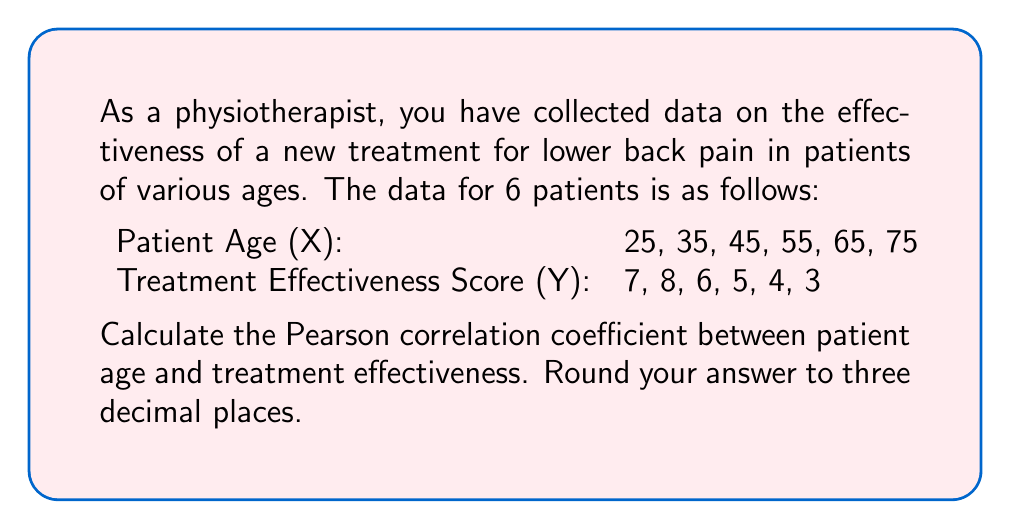Give your solution to this math problem. To calculate the Pearson correlation coefficient, we'll use the formula:

$$ r = \frac{n\sum xy - \sum x \sum y}{\sqrt{[n\sum x^2 - (\sum x)^2][n\sum y^2 - (\sum y)^2]}} $$

Where:
$n$ = number of pairs of data
$x$ = patient age
$y$ = treatment effectiveness score

Step 1: Calculate the required sums:
$n = 6$
$\sum x = 25 + 35 + 45 + 55 + 65 + 75 = 300$
$\sum y = 7 + 8 + 6 + 5 + 4 + 3 = 33$
$\sum xy = (25 \times 7) + (35 \times 8) + (45 \times 6) + (55 \times 5) + (65 \times 4) + (75 \times 3) = 1525$
$\sum x^2 = 25^2 + 35^2 + 45^2 + 55^2 + 65^2 + 75^2 = 16,250$
$\sum y^2 = 7^2 + 8^2 + 6^2 + 5^2 + 4^2 + 3^2 = 203$

Step 2: Substitute these values into the formula:

$$ r = \frac{6(1525) - (300)(33)}{\sqrt{[6(16,250) - (300)^2][6(203) - (33)^2]}} $$

Step 3: Simplify:

$$ r = \frac{9150 - 9900}{\sqrt{(97,500 - 90,000)(1218 - 1089)}} $$

$$ r = \frac{-750}{\sqrt{(7500)(129)}} $$

$$ r = \frac{-750}{\sqrt{967,500}} $$

$$ r = \frac{-750}{983.11} $$

Step 4: Calculate and round to three decimal places:

$$ r \approx -0.763 $$
Answer: $-0.763$ 